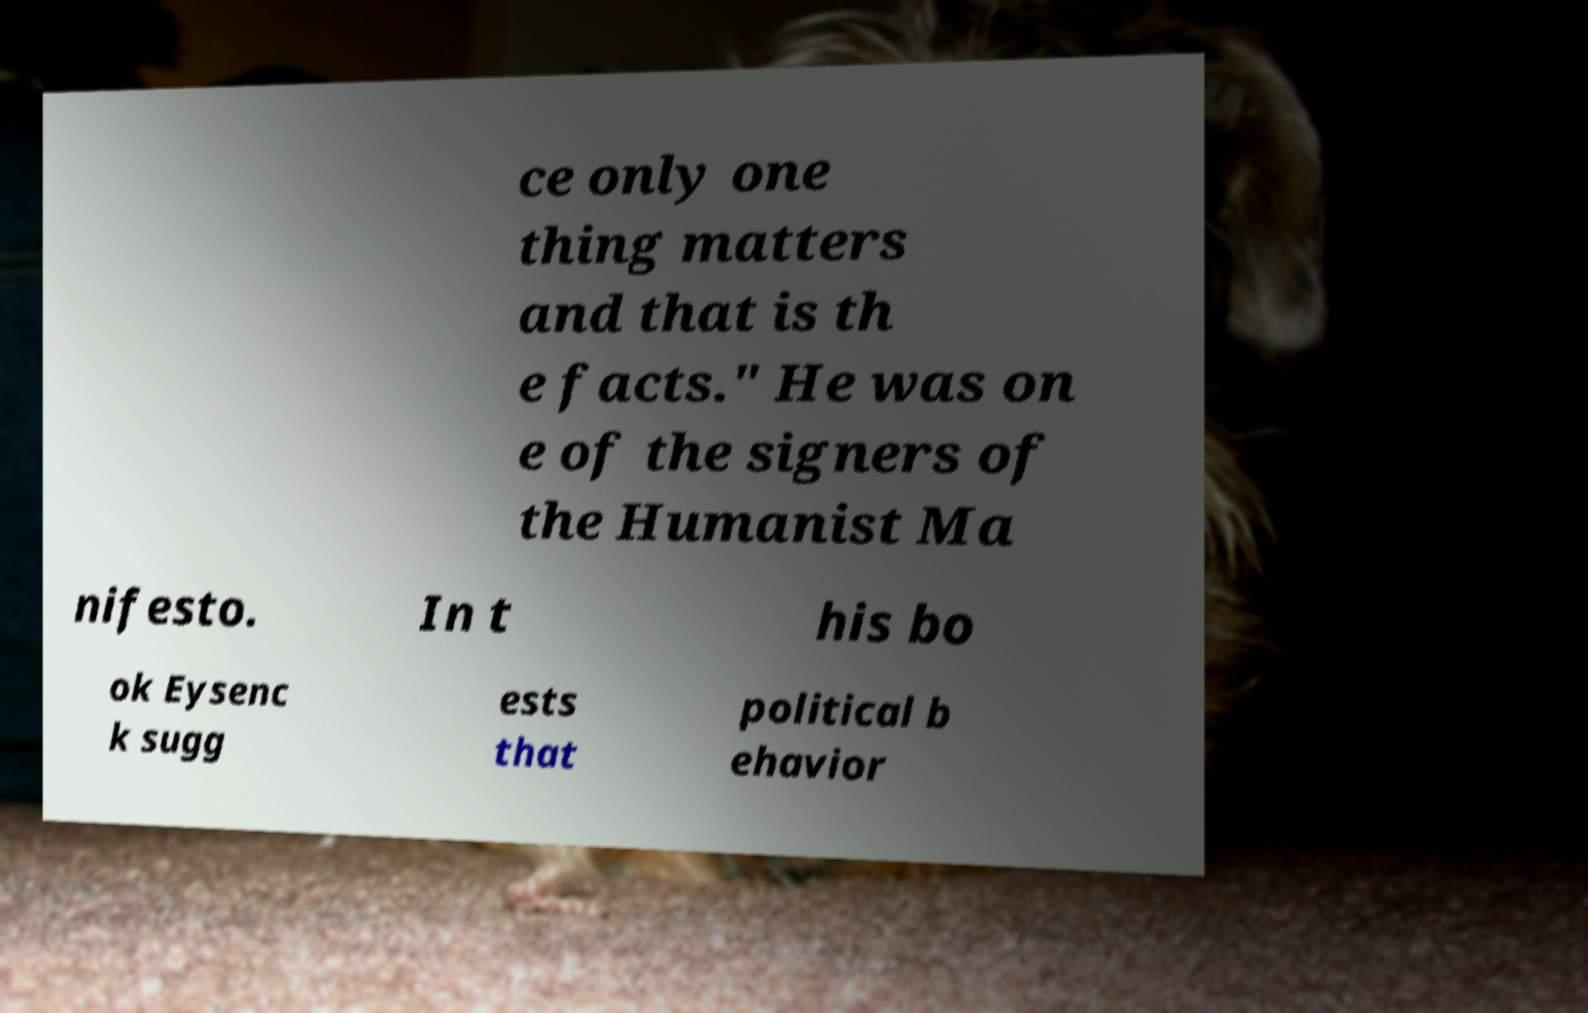Please identify and transcribe the text found in this image. ce only one thing matters and that is th e facts." He was on e of the signers of the Humanist Ma nifesto. In t his bo ok Eysenc k sugg ests that political b ehavior 